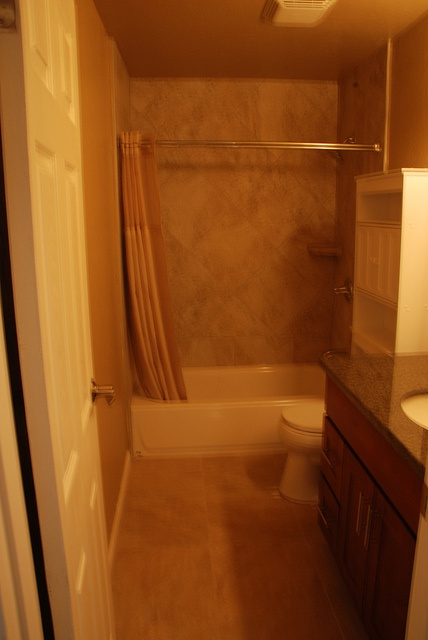Describe the objects in this image and their specific colors. I can see toilet in maroon and red tones and sink in maroon, orange, and red tones in this image. 